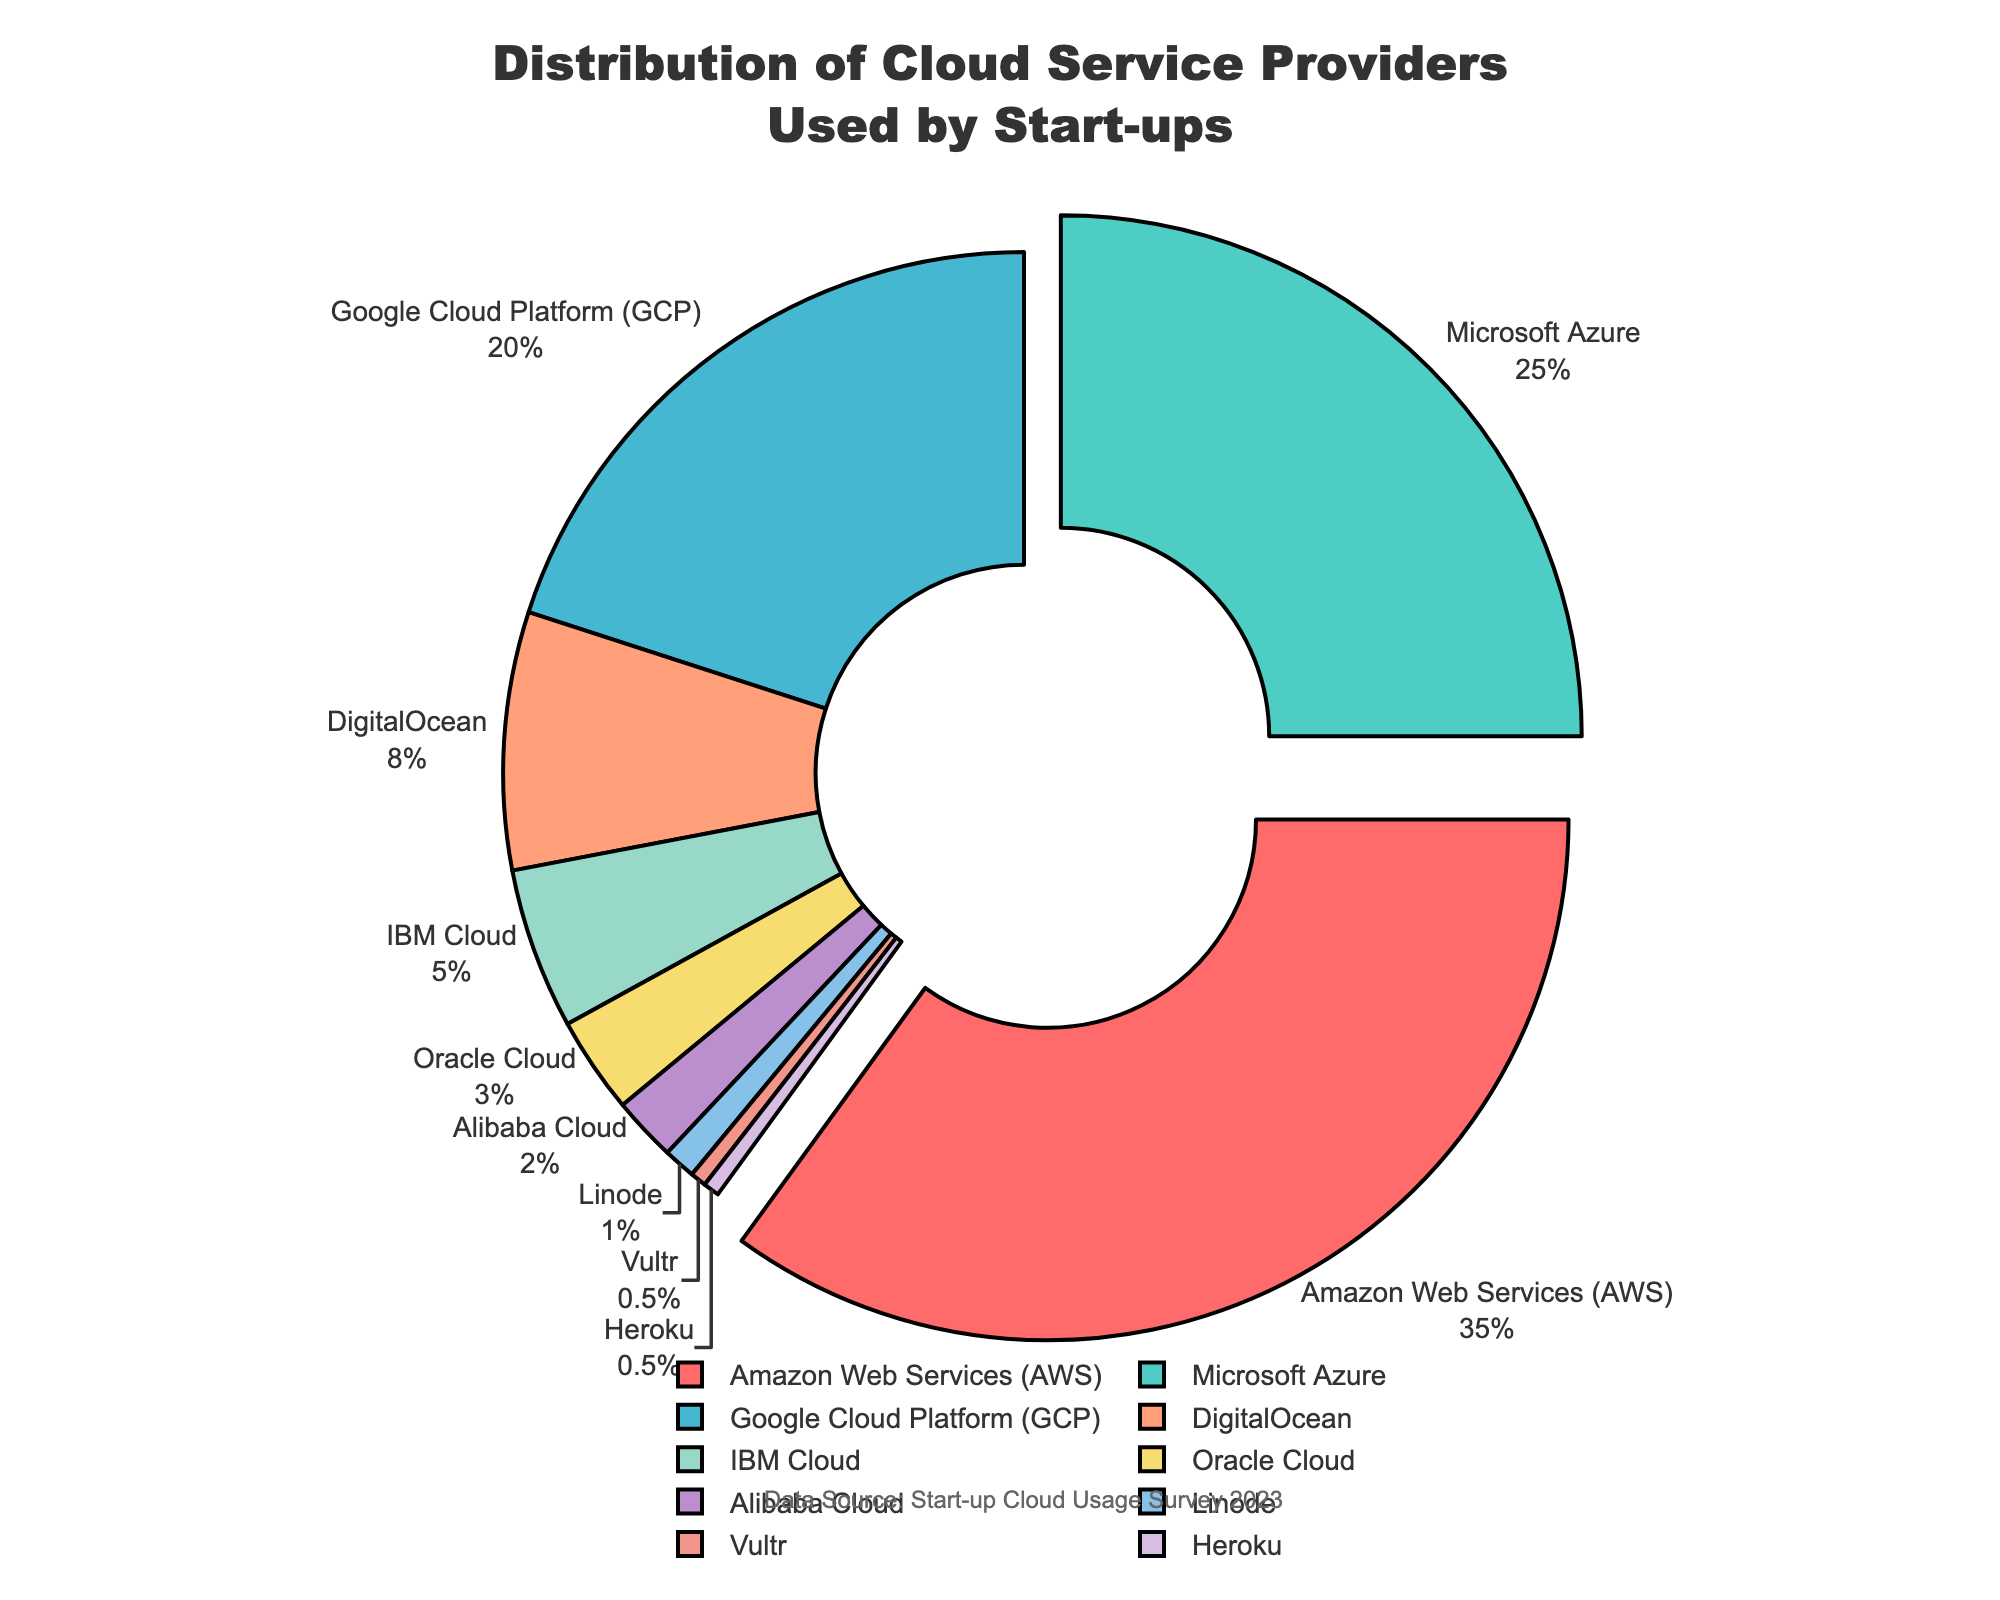Which cloud service provider is used the most by start-ups? According to the figure, Amazon Web Services (AWS) has the highest percentage at 35%. This indicates that AWS is the most used cloud service provider among start-ups.
Answer: Amazon Web Services (AWS) Which cloud service provider is used the least by start-ups? The figure shows that Linode and Heroku both have the smallest percentage at 0.5%. This indicates that they are the least used cloud service providers among start-ups.
Answer: Linode and Heroku How much more popular is Amazon Web Services (AWS) compared to Oracle Cloud among start-ups? AWS has 35% while Oracle Cloud has 3%. The difference is 35% - 3% = 32%. This means AWS is 32 percentage points more popular than Oracle Cloud.
Answer: 32% What is the combined percentage of start-ups using IBM Cloud and Oracle Cloud? According to the figure, IBM Cloud is at 5% and Oracle Cloud is at 3%. Adding them gives 5% + 3% = 8%.
Answer: 8% Which three cloud service providers have the largest market share among start-ups? The three cloud service providers with the largest percentages are Amazon Web Services (35%), Microsoft Azure (25%), and Google Cloud Platform (20%).
Answer: Amazon Web Services, Microsoft Azure, Google Cloud Platform Of the top three cloud service providers, which one has the smallest percentage? The top three cloud service providers are Amazon Web Services (35%), Microsoft Azure (25%), and Google Cloud Platform (20%). Among these, Google Cloud Platform has the smallest percentage at 20%.
Answer: Google Cloud Platform What percentage of start-ups use providers other than Amazon Web Services, Microsoft Azure, and Google Cloud Platform? The combined percentage for AWS, Microsoft Azure, and Google Cloud Platform is 35% + 25% + 20% = 80%. Therefore, 100% - 80% = 20% of start-ups use other providers.
Answer: 20% If the percentage of start-ups using DigitalOcean increased by 5%, what would be its new percentage? Currently, DigitalOcean has 8%. If it increased by 5%, the new percentage would be 8% + 5% = 13%.
Answer: 13% How does the percentage of start-ups using Amazon Web Services compare to those using DigitalOcean and IBM Cloud combined? The percentage for AWS is 35%. DigitalOcean and IBM Cloud combined is 8% + 5% = 13%. AWS is significantly higher than the combined usage of DigitalOcean and IBM Cloud.
Answer: AWS is higher Is the usage of Microsoft Azure among start-ups more than double that of Google Cloud Platform? Microsoft Azure has 25% and Google Cloud Platform has 20%. 25% is not more than double of 20% (which would be 40%), so it is less than double.
Answer: No 